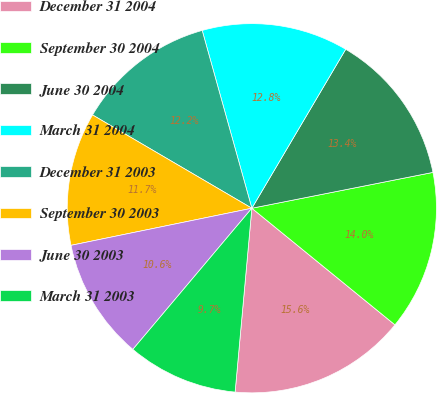Convert chart. <chart><loc_0><loc_0><loc_500><loc_500><pie_chart><fcel>December 31 2004<fcel>September 30 2004<fcel>June 30 2004<fcel>March 31 2004<fcel>December 31 2003<fcel>September 30 2003<fcel>June 30 2003<fcel>March 31 2003<nl><fcel>15.56%<fcel>13.99%<fcel>13.4%<fcel>12.82%<fcel>12.23%<fcel>11.65%<fcel>10.63%<fcel>9.7%<nl></chart> 